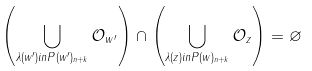<formula> <loc_0><loc_0><loc_500><loc_500>\left ( \bigcup _ { \lambda ( w ^ { \prime } ) i n P ( w ^ { \prime } ) _ { n + k } } \mathcal { O } _ { w ^ { \prime } } \right ) \cap \left ( \bigcup _ { \lambda ( z ) i n P ( w ) _ { n + k } } \mathcal { O } _ { z } \right ) = \varnothing</formula> 